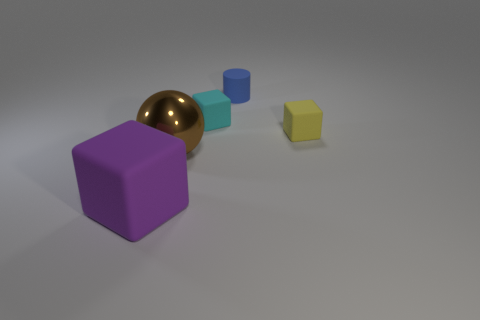If these objects were part of a game, what kind of game do you imagine it could be? These objects could belong to an educational game designed for young children, focusing on shape and color recognition. Players could be challenged to match similarly shaped and colored objects, or perhaps solve puzzles that require them to place the objects in specific arrangements based on size or color sequences. 